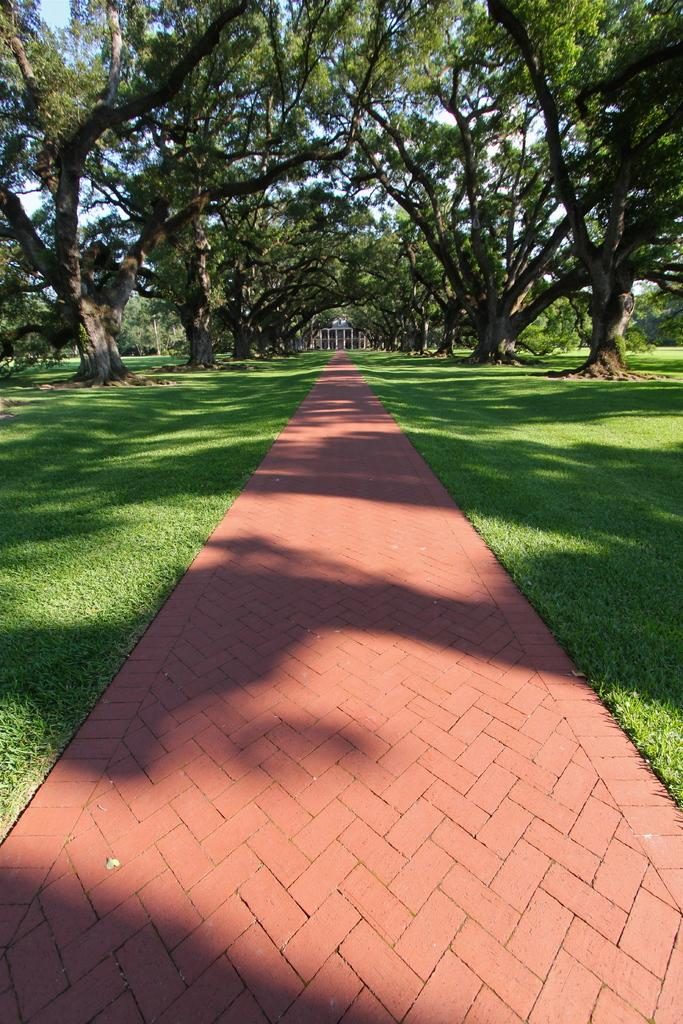What can be seen in the foreground of the image? There is a path in the image. What is visible in the background of the image? Trees and grassland are visible in the background of the image. What structure is located in the middle of the image? There is a building in the middle of the image. How many kittens are playing with a net in the image? There are no kittens or nets present in the image. What arithmetic problem is being solved on the building in the image? There is no arithmetic problem visible on the building in the image. 